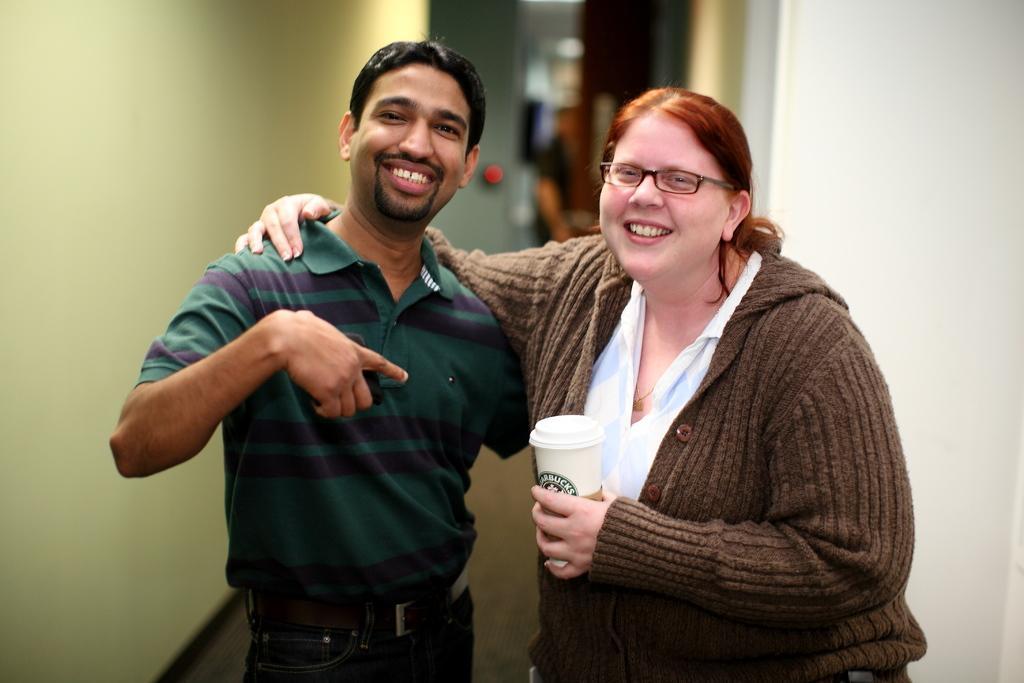How would you summarize this image in a sentence or two? In this image, we can see persons in between walls. These two persons are wearing clothes. There is a person on the right side of the image holding a cup with her hand. 